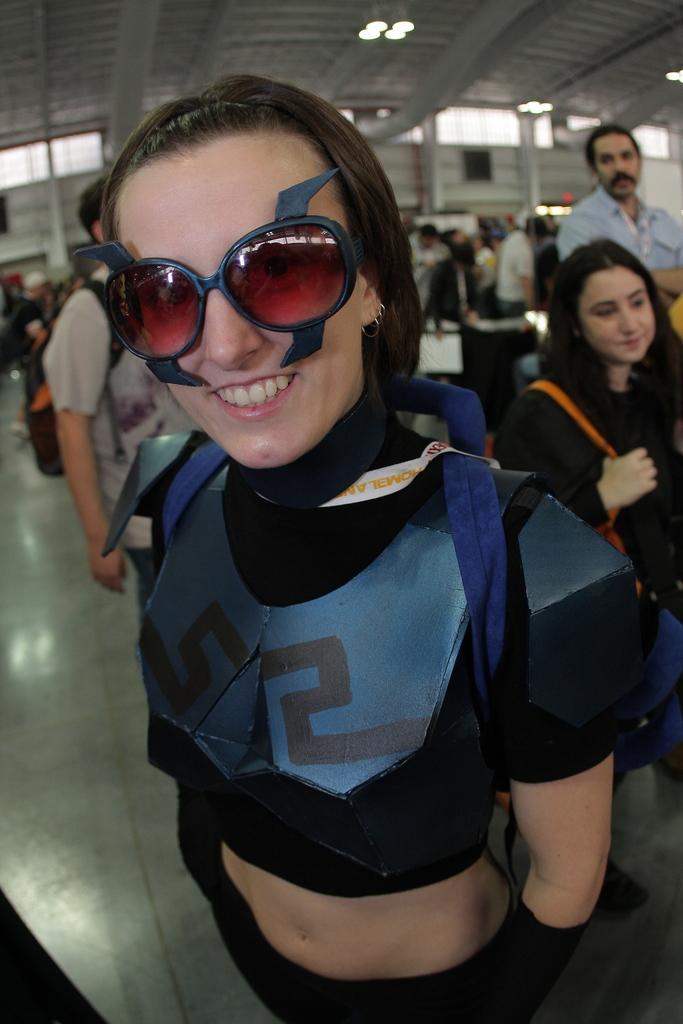Could you give a brief overview of what you see in this image? In the middle of this image, there is a woman in a black color dress, wearing sunglasses, smiling and standing. In the background, there are other persons and there are lights attached to the roof. 